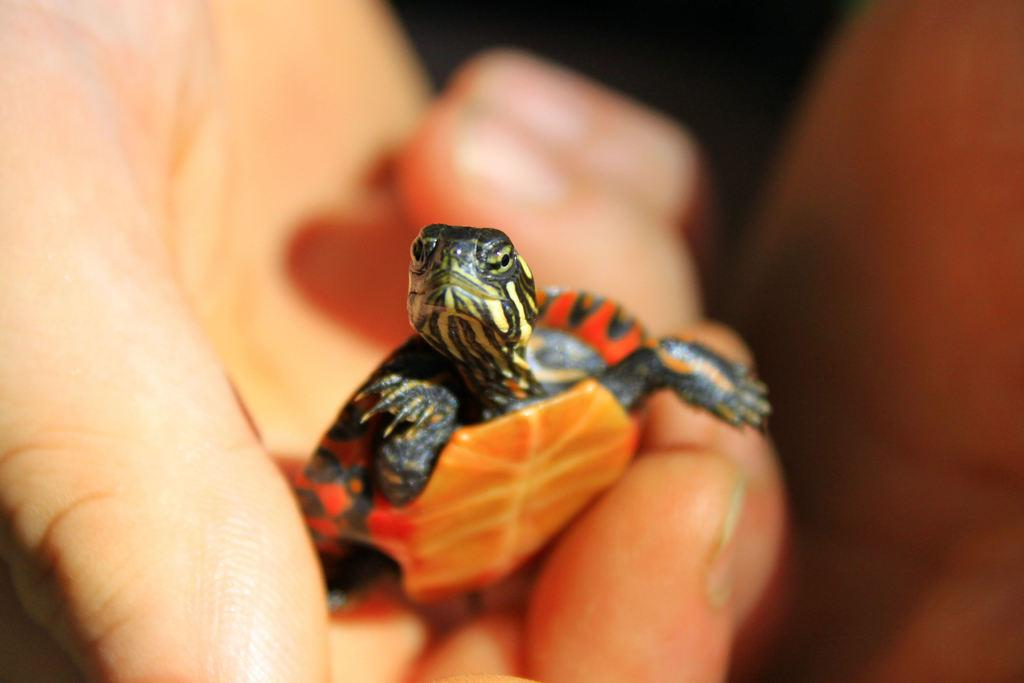What is the person holding in the image? The person is holding a reptile in the image. Can you describe the background of the image? The background of the image is blurred. What type of trousers is the person wearing in the image? The provided facts do not mention any trousers or clothing worn by the person in the image. 